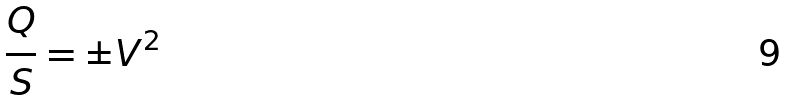<formula> <loc_0><loc_0><loc_500><loc_500>\frac { Q } { S } = \pm V ^ { 2 }</formula> 